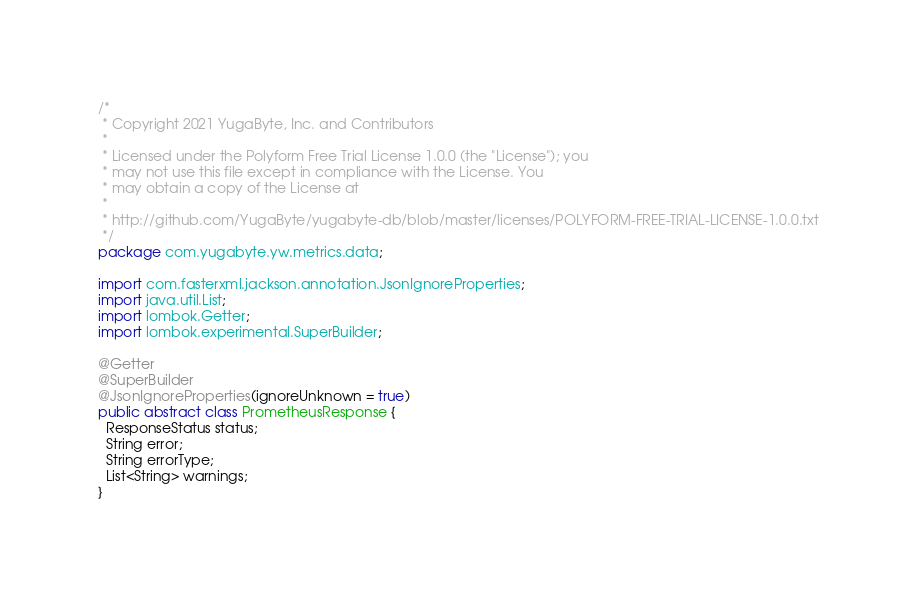Convert code to text. <code><loc_0><loc_0><loc_500><loc_500><_Java_>/*
 * Copyright 2021 YugaByte, Inc. and Contributors
 *
 * Licensed under the Polyform Free Trial License 1.0.0 (the "License"); you
 * may not use this file except in compliance with the License. You
 * may obtain a copy of the License at
 *
 * http://github.com/YugaByte/yugabyte-db/blob/master/licenses/POLYFORM-FREE-TRIAL-LICENSE-1.0.0.txt
 */
package com.yugabyte.yw.metrics.data;

import com.fasterxml.jackson.annotation.JsonIgnoreProperties;
import java.util.List;
import lombok.Getter;
import lombok.experimental.SuperBuilder;

@Getter
@SuperBuilder
@JsonIgnoreProperties(ignoreUnknown = true)
public abstract class PrometheusResponse {
  ResponseStatus status;
  String error;
  String errorType;
  List<String> warnings;
}
</code> 